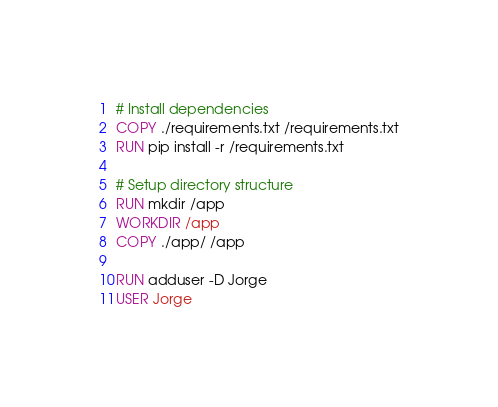<code> <loc_0><loc_0><loc_500><loc_500><_Dockerfile_>
# Install dependencies
COPY ./requirements.txt /requirements.txt
RUN pip install -r /requirements.txt

# Setup directory structure
RUN mkdir /app
WORKDIR /app
COPY ./app/ /app

RUN adduser -D Jorge
USER Jorge</code> 